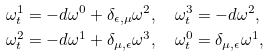Convert formula to latex. <formula><loc_0><loc_0><loc_500><loc_500>& \omega ^ { 1 } _ { t } = - d \omega ^ { 0 } + \delta _ { \epsilon , \mu } \omega ^ { 2 } , \quad \omega ^ { 3 } _ { t } = - d \omega ^ { 2 } , \\ & \omega ^ { 2 } _ { t } = - d \omega ^ { 1 } + \delta _ { \mu , \epsilon } \omega ^ { 3 } , \quad \omega ^ { 0 } _ { t } = \delta _ { \mu , \epsilon } \omega ^ { 1 } ,</formula> 